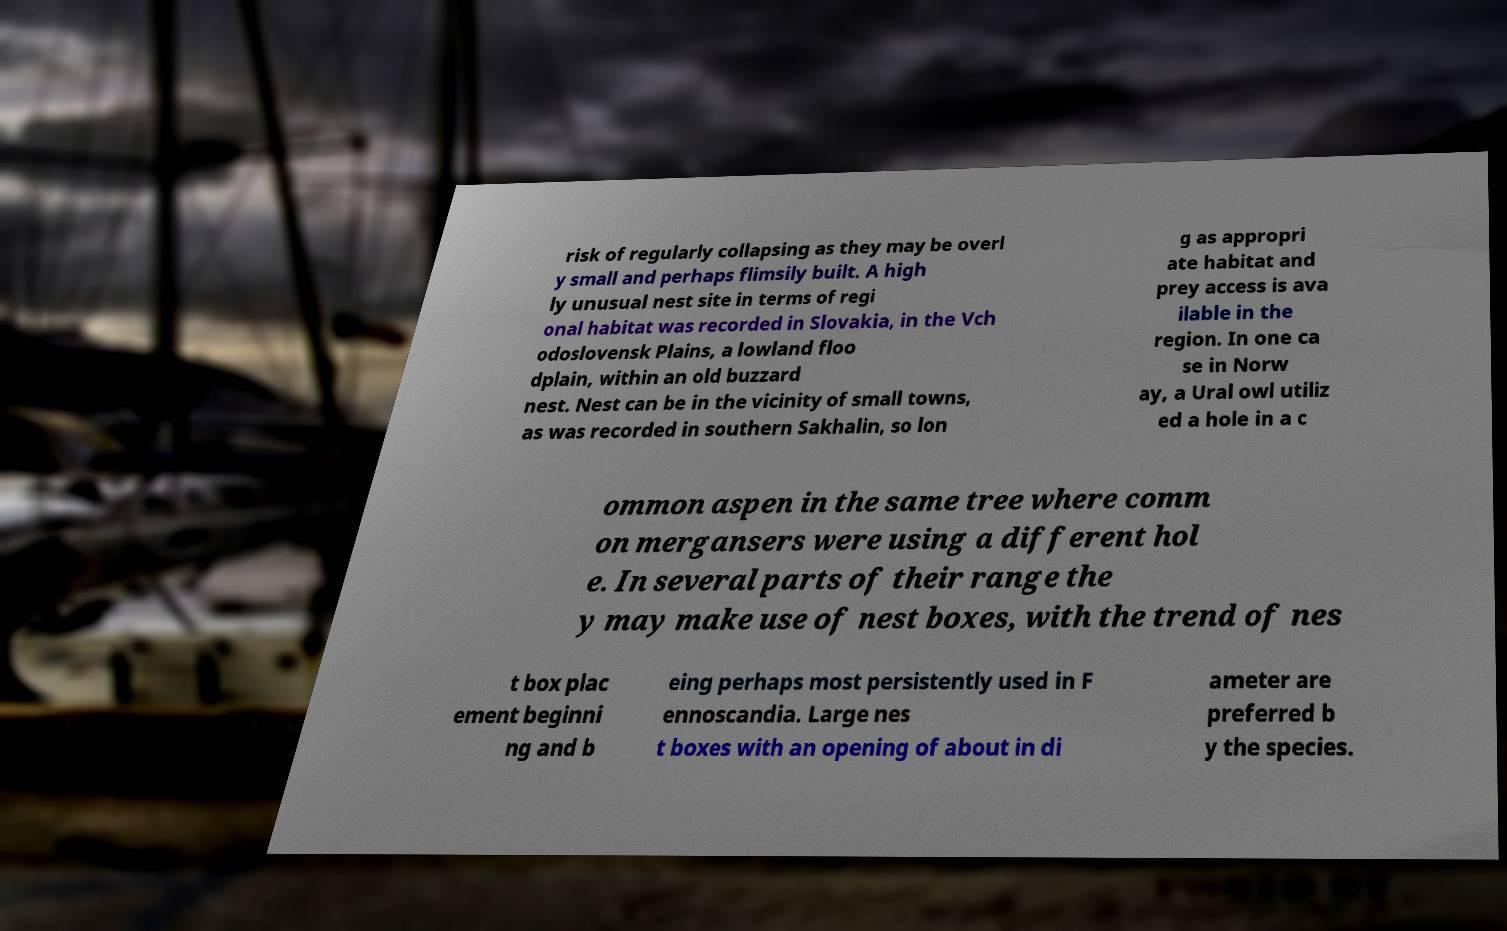Please read and relay the text visible in this image. What does it say? risk of regularly collapsing as they may be overl y small and perhaps flimsily built. A high ly unusual nest site in terms of regi onal habitat was recorded in Slovakia, in the Vch odoslovensk Plains, a lowland floo dplain, within an old buzzard nest. Nest can be in the vicinity of small towns, as was recorded in southern Sakhalin, so lon g as appropri ate habitat and prey access is ava ilable in the region. In one ca se in Norw ay, a Ural owl utiliz ed a hole in a c ommon aspen in the same tree where comm on mergansers were using a different hol e. In several parts of their range the y may make use of nest boxes, with the trend of nes t box plac ement beginni ng and b eing perhaps most persistently used in F ennoscandia. Large nes t boxes with an opening of about in di ameter are preferred b y the species. 